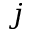<formula> <loc_0><loc_0><loc_500><loc_500>j</formula> 